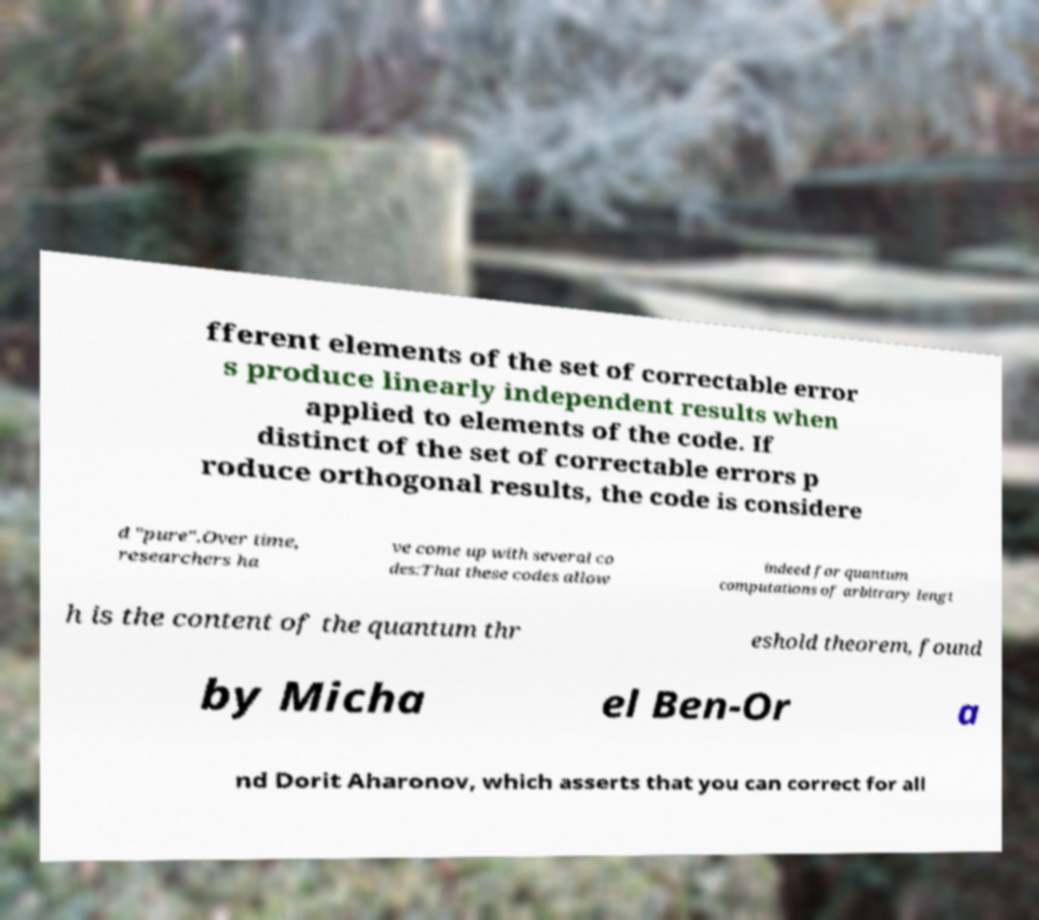For documentation purposes, I need the text within this image transcribed. Could you provide that? fferent elements of the set of correctable error s produce linearly independent results when applied to elements of the code. If distinct of the set of correctable errors p roduce orthogonal results, the code is considere d "pure".Over time, researchers ha ve come up with several co des:That these codes allow indeed for quantum computations of arbitrary lengt h is the content of the quantum thr eshold theorem, found by Micha el Ben-Or a nd Dorit Aharonov, which asserts that you can correct for all 